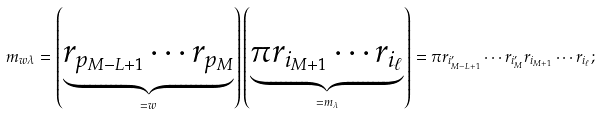<formula> <loc_0><loc_0><loc_500><loc_500>m _ { w \lambda } = \left ( \underbrace { r _ { p _ { M - L + 1 } } \cdots r _ { p _ { M } } } _ { = w } \right ) \left ( \underbrace { \pi r _ { i _ { M + 1 } } \cdots r _ { i _ { \ell } } } _ { = m _ { \lambda } } \right ) = \pi r _ { i _ { M - L + 1 } ^ { \prime } } \cdots r _ { i _ { M } ^ { \prime } } r _ { i _ { M + 1 } } \cdots r _ { i _ { \ell } } ;</formula> 